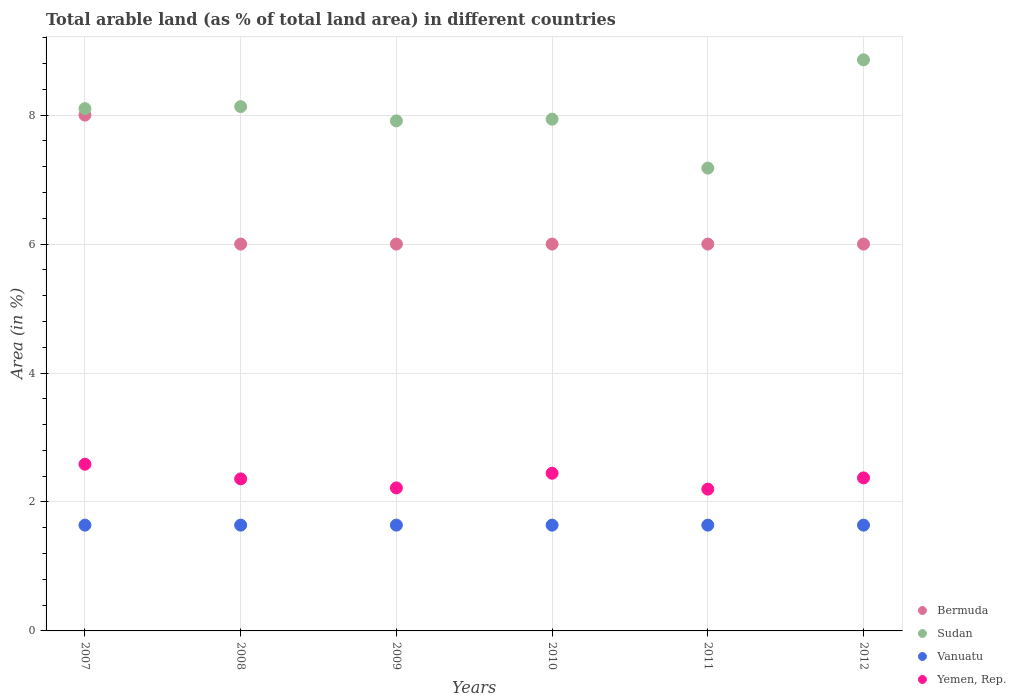How many different coloured dotlines are there?
Your answer should be very brief. 4. Is the number of dotlines equal to the number of legend labels?
Your answer should be very brief. Yes. What is the percentage of arable land in Yemen, Rep. in 2010?
Keep it short and to the point. 2.45. Across all years, what is the maximum percentage of arable land in Yemen, Rep.?
Keep it short and to the point. 2.59. Across all years, what is the minimum percentage of arable land in Yemen, Rep.?
Make the answer very short. 2.2. In which year was the percentage of arable land in Sudan minimum?
Your answer should be compact. 2011. What is the total percentage of arable land in Yemen, Rep. in the graph?
Provide a succinct answer. 14.18. What is the difference between the percentage of arable land in Bermuda in 2007 and that in 2009?
Ensure brevity in your answer.  2. What is the difference between the percentage of arable land in Sudan in 2008 and the percentage of arable land in Vanuatu in 2009?
Your answer should be very brief. 6.49. What is the average percentage of arable land in Sudan per year?
Provide a short and direct response. 8.02. In the year 2008, what is the difference between the percentage of arable land in Bermuda and percentage of arable land in Sudan?
Offer a very short reply. -2.13. Is the difference between the percentage of arable land in Bermuda in 2008 and 2012 greater than the difference between the percentage of arable land in Sudan in 2008 and 2012?
Provide a succinct answer. Yes. What is the difference between the highest and the second highest percentage of arable land in Sudan?
Your answer should be compact. 0.73. What is the difference between the highest and the lowest percentage of arable land in Sudan?
Provide a short and direct response. 1.68. Is it the case that in every year, the sum of the percentage of arable land in Vanuatu and percentage of arable land in Sudan  is greater than the sum of percentage of arable land in Yemen, Rep. and percentage of arable land in Bermuda?
Your answer should be very brief. No. Is it the case that in every year, the sum of the percentage of arable land in Sudan and percentage of arable land in Vanuatu  is greater than the percentage of arable land in Yemen, Rep.?
Your answer should be compact. Yes. Does the percentage of arable land in Bermuda monotonically increase over the years?
Your answer should be compact. No. How many dotlines are there?
Provide a short and direct response. 4. How many years are there in the graph?
Your answer should be very brief. 6. What is the difference between two consecutive major ticks on the Y-axis?
Provide a short and direct response. 2. Does the graph contain any zero values?
Provide a succinct answer. No. Where does the legend appear in the graph?
Your response must be concise. Bottom right. How many legend labels are there?
Offer a very short reply. 4. How are the legend labels stacked?
Offer a terse response. Vertical. What is the title of the graph?
Ensure brevity in your answer.  Total arable land (as % of total land area) in different countries. Does "St. Lucia" appear as one of the legend labels in the graph?
Keep it short and to the point. No. What is the label or title of the Y-axis?
Your answer should be very brief. Area (in %). What is the Area (in %) in Sudan in 2007?
Offer a terse response. 8.1. What is the Area (in %) in Vanuatu in 2007?
Your answer should be very brief. 1.64. What is the Area (in %) of Yemen, Rep. in 2007?
Ensure brevity in your answer.  2.59. What is the Area (in %) in Bermuda in 2008?
Provide a succinct answer. 6. What is the Area (in %) in Sudan in 2008?
Your answer should be very brief. 8.13. What is the Area (in %) in Vanuatu in 2008?
Provide a short and direct response. 1.64. What is the Area (in %) of Yemen, Rep. in 2008?
Offer a very short reply. 2.36. What is the Area (in %) in Sudan in 2009?
Your answer should be very brief. 7.91. What is the Area (in %) in Vanuatu in 2009?
Your answer should be very brief. 1.64. What is the Area (in %) of Yemen, Rep. in 2009?
Your response must be concise. 2.22. What is the Area (in %) of Bermuda in 2010?
Keep it short and to the point. 6. What is the Area (in %) of Sudan in 2010?
Keep it short and to the point. 7.94. What is the Area (in %) in Vanuatu in 2010?
Provide a succinct answer. 1.64. What is the Area (in %) of Yemen, Rep. in 2010?
Offer a terse response. 2.45. What is the Area (in %) of Bermuda in 2011?
Provide a short and direct response. 6. What is the Area (in %) in Sudan in 2011?
Keep it short and to the point. 7.18. What is the Area (in %) in Vanuatu in 2011?
Ensure brevity in your answer.  1.64. What is the Area (in %) in Yemen, Rep. in 2011?
Provide a short and direct response. 2.2. What is the Area (in %) in Bermuda in 2012?
Provide a short and direct response. 6. What is the Area (in %) of Sudan in 2012?
Provide a succinct answer. 8.86. What is the Area (in %) in Vanuatu in 2012?
Keep it short and to the point. 1.64. What is the Area (in %) of Yemen, Rep. in 2012?
Your answer should be very brief. 2.37. Across all years, what is the maximum Area (in %) of Bermuda?
Offer a very short reply. 8. Across all years, what is the maximum Area (in %) in Sudan?
Provide a succinct answer. 8.86. Across all years, what is the maximum Area (in %) in Vanuatu?
Offer a terse response. 1.64. Across all years, what is the maximum Area (in %) of Yemen, Rep.?
Ensure brevity in your answer.  2.59. Across all years, what is the minimum Area (in %) of Sudan?
Offer a very short reply. 7.18. Across all years, what is the minimum Area (in %) of Vanuatu?
Provide a succinct answer. 1.64. Across all years, what is the minimum Area (in %) of Yemen, Rep.?
Provide a short and direct response. 2.2. What is the total Area (in %) of Sudan in the graph?
Make the answer very short. 48.12. What is the total Area (in %) of Vanuatu in the graph?
Offer a very short reply. 9.84. What is the total Area (in %) in Yemen, Rep. in the graph?
Provide a succinct answer. 14.18. What is the difference between the Area (in %) of Sudan in 2007 and that in 2008?
Offer a terse response. -0.03. What is the difference between the Area (in %) in Yemen, Rep. in 2007 and that in 2008?
Provide a succinct answer. 0.23. What is the difference between the Area (in %) of Bermuda in 2007 and that in 2009?
Give a very brief answer. 2. What is the difference between the Area (in %) of Sudan in 2007 and that in 2009?
Provide a succinct answer. 0.19. What is the difference between the Area (in %) in Yemen, Rep. in 2007 and that in 2009?
Offer a very short reply. 0.37. What is the difference between the Area (in %) in Sudan in 2007 and that in 2010?
Offer a terse response. 0.16. What is the difference between the Area (in %) of Vanuatu in 2007 and that in 2010?
Your answer should be compact. 0. What is the difference between the Area (in %) in Yemen, Rep. in 2007 and that in 2010?
Your answer should be very brief. 0.14. What is the difference between the Area (in %) in Sudan in 2007 and that in 2011?
Offer a terse response. 0.92. What is the difference between the Area (in %) in Yemen, Rep. in 2007 and that in 2011?
Your response must be concise. 0.39. What is the difference between the Area (in %) of Sudan in 2007 and that in 2012?
Make the answer very short. -0.76. What is the difference between the Area (in %) of Vanuatu in 2007 and that in 2012?
Your response must be concise. 0. What is the difference between the Area (in %) in Yemen, Rep. in 2007 and that in 2012?
Ensure brevity in your answer.  0.21. What is the difference between the Area (in %) of Bermuda in 2008 and that in 2009?
Ensure brevity in your answer.  0. What is the difference between the Area (in %) in Sudan in 2008 and that in 2009?
Make the answer very short. 0.22. What is the difference between the Area (in %) of Yemen, Rep. in 2008 and that in 2009?
Keep it short and to the point. 0.14. What is the difference between the Area (in %) in Bermuda in 2008 and that in 2010?
Provide a succinct answer. 0. What is the difference between the Area (in %) of Sudan in 2008 and that in 2010?
Keep it short and to the point. 0.19. What is the difference between the Area (in %) of Yemen, Rep. in 2008 and that in 2010?
Provide a succinct answer. -0.09. What is the difference between the Area (in %) in Sudan in 2008 and that in 2011?
Make the answer very short. 0.95. What is the difference between the Area (in %) in Yemen, Rep. in 2008 and that in 2011?
Your response must be concise. 0.16. What is the difference between the Area (in %) of Sudan in 2008 and that in 2012?
Your answer should be very brief. -0.73. What is the difference between the Area (in %) of Vanuatu in 2008 and that in 2012?
Make the answer very short. 0. What is the difference between the Area (in %) of Yemen, Rep. in 2008 and that in 2012?
Make the answer very short. -0.02. What is the difference between the Area (in %) of Bermuda in 2009 and that in 2010?
Provide a short and direct response. 0. What is the difference between the Area (in %) of Sudan in 2009 and that in 2010?
Offer a very short reply. -0.03. What is the difference between the Area (in %) in Yemen, Rep. in 2009 and that in 2010?
Your response must be concise. -0.23. What is the difference between the Area (in %) of Bermuda in 2009 and that in 2011?
Offer a terse response. 0. What is the difference between the Area (in %) in Sudan in 2009 and that in 2011?
Offer a terse response. 0.73. What is the difference between the Area (in %) of Vanuatu in 2009 and that in 2011?
Offer a very short reply. 0. What is the difference between the Area (in %) of Yemen, Rep. in 2009 and that in 2011?
Keep it short and to the point. 0.02. What is the difference between the Area (in %) in Sudan in 2009 and that in 2012?
Your answer should be compact. -0.95. What is the difference between the Area (in %) in Vanuatu in 2009 and that in 2012?
Make the answer very short. 0. What is the difference between the Area (in %) of Yemen, Rep. in 2009 and that in 2012?
Make the answer very short. -0.16. What is the difference between the Area (in %) of Bermuda in 2010 and that in 2011?
Your response must be concise. 0. What is the difference between the Area (in %) in Sudan in 2010 and that in 2011?
Your answer should be very brief. 0.76. What is the difference between the Area (in %) in Yemen, Rep. in 2010 and that in 2011?
Provide a short and direct response. 0.25. What is the difference between the Area (in %) of Bermuda in 2010 and that in 2012?
Your response must be concise. 0. What is the difference between the Area (in %) in Sudan in 2010 and that in 2012?
Provide a short and direct response. -0.92. What is the difference between the Area (in %) of Yemen, Rep. in 2010 and that in 2012?
Provide a succinct answer. 0.07. What is the difference between the Area (in %) of Bermuda in 2011 and that in 2012?
Your response must be concise. 0. What is the difference between the Area (in %) in Sudan in 2011 and that in 2012?
Give a very brief answer. -1.68. What is the difference between the Area (in %) in Yemen, Rep. in 2011 and that in 2012?
Offer a terse response. -0.17. What is the difference between the Area (in %) of Bermuda in 2007 and the Area (in %) of Sudan in 2008?
Give a very brief answer. -0.13. What is the difference between the Area (in %) of Bermuda in 2007 and the Area (in %) of Vanuatu in 2008?
Make the answer very short. 6.36. What is the difference between the Area (in %) of Bermuda in 2007 and the Area (in %) of Yemen, Rep. in 2008?
Your answer should be very brief. 5.64. What is the difference between the Area (in %) in Sudan in 2007 and the Area (in %) in Vanuatu in 2008?
Offer a very short reply. 6.46. What is the difference between the Area (in %) in Sudan in 2007 and the Area (in %) in Yemen, Rep. in 2008?
Keep it short and to the point. 5.74. What is the difference between the Area (in %) of Vanuatu in 2007 and the Area (in %) of Yemen, Rep. in 2008?
Your response must be concise. -0.72. What is the difference between the Area (in %) of Bermuda in 2007 and the Area (in %) of Sudan in 2009?
Make the answer very short. 0.09. What is the difference between the Area (in %) of Bermuda in 2007 and the Area (in %) of Vanuatu in 2009?
Keep it short and to the point. 6.36. What is the difference between the Area (in %) of Bermuda in 2007 and the Area (in %) of Yemen, Rep. in 2009?
Offer a terse response. 5.78. What is the difference between the Area (in %) of Sudan in 2007 and the Area (in %) of Vanuatu in 2009?
Your answer should be very brief. 6.46. What is the difference between the Area (in %) of Sudan in 2007 and the Area (in %) of Yemen, Rep. in 2009?
Make the answer very short. 5.88. What is the difference between the Area (in %) of Vanuatu in 2007 and the Area (in %) of Yemen, Rep. in 2009?
Provide a short and direct response. -0.58. What is the difference between the Area (in %) in Bermuda in 2007 and the Area (in %) in Sudan in 2010?
Give a very brief answer. 0.06. What is the difference between the Area (in %) of Bermuda in 2007 and the Area (in %) of Vanuatu in 2010?
Offer a very short reply. 6.36. What is the difference between the Area (in %) in Bermuda in 2007 and the Area (in %) in Yemen, Rep. in 2010?
Your response must be concise. 5.55. What is the difference between the Area (in %) of Sudan in 2007 and the Area (in %) of Vanuatu in 2010?
Make the answer very short. 6.46. What is the difference between the Area (in %) of Sudan in 2007 and the Area (in %) of Yemen, Rep. in 2010?
Offer a very short reply. 5.66. What is the difference between the Area (in %) of Vanuatu in 2007 and the Area (in %) of Yemen, Rep. in 2010?
Your answer should be very brief. -0.8. What is the difference between the Area (in %) in Bermuda in 2007 and the Area (in %) in Sudan in 2011?
Give a very brief answer. 0.82. What is the difference between the Area (in %) in Bermuda in 2007 and the Area (in %) in Vanuatu in 2011?
Offer a very short reply. 6.36. What is the difference between the Area (in %) in Bermuda in 2007 and the Area (in %) in Yemen, Rep. in 2011?
Make the answer very short. 5.8. What is the difference between the Area (in %) in Sudan in 2007 and the Area (in %) in Vanuatu in 2011?
Offer a terse response. 6.46. What is the difference between the Area (in %) of Sudan in 2007 and the Area (in %) of Yemen, Rep. in 2011?
Offer a very short reply. 5.9. What is the difference between the Area (in %) of Vanuatu in 2007 and the Area (in %) of Yemen, Rep. in 2011?
Provide a short and direct response. -0.56. What is the difference between the Area (in %) in Bermuda in 2007 and the Area (in %) in Sudan in 2012?
Offer a terse response. -0.86. What is the difference between the Area (in %) in Bermuda in 2007 and the Area (in %) in Vanuatu in 2012?
Your answer should be compact. 6.36. What is the difference between the Area (in %) of Bermuda in 2007 and the Area (in %) of Yemen, Rep. in 2012?
Your response must be concise. 5.63. What is the difference between the Area (in %) of Sudan in 2007 and the Area (in %) of Vanuatu in 2012?
Make the answer very short. 6.46. What is the difference between the Area (in %) of Sudan in 2007 and the Area (in %) of Yemen, Rep. in 2012?
Offer a terse response. 5.73. What is the difference between the Area (in %) of Vanuatu in 2007 and the Area (in %) of Yemen, Rep. in 2012?
Provide a succinct answer. -0.73. What is the difference between the Area (in %) in Bermuda in 2008 and the Area (in %) in Sudan in 2009?
Give a very brief answer. -1.91. What is the difference between the Area (in %) in Bermuda in 2008 and the Area (in %) in Vanuatu in 2009?
Ensure brevity in your answer.  4.36. What is the difference between the Area (in %) in Bermuda in 2008 and the Area (in %) in Yemen, Rep. in 2009?
Your answer should be compact. 3.78. What is the difference between the Area (in %) in Sudan in 2008 and the Area (in %) in Vanuatu in 2009?
Give a very brief answer. 6.49. What is the difference between the Area (in %) in Sudan in 2008 and the Area (in %) in Yemen, Rep. in 2009?
Offer a very short reply. 5.91. What is the difference between the Area (in %) in Vanuatu in 2008 and the Area (in %) in Yemen, Rep. in 2009?
Give a very brief answer. -0.58. What is the difference between the Area (in %) of Bermuda in 2008 and the Area (in %) of Sudan in 2010?
Your response must be concise. -1.94. What is the difference between the Area (in %) of Bermuda in 2008 and the Area (in %) of Vanuatu in 2010?
Offer a terse response. 4.36. What is the difference between the Area (in %) in Bermuda in 2008 and the Area (in %) in Yemen, Rep. in 2010?
Your answer should be compact. 3.55. What is the difference between the Area (in %) in Sudan in 2008 and the Area (in %) in Vanuatu in 2010?
Keep it short and to the point. 6.49. What is the difference between the Area (in %) of Sudan in 2008 and the Area (in %) of Yemen, Rep. in 2010?
Make the answer very short. 5.69. What is the difference between the Area (in %) in Vanuatu in 2008 and the Area (in %) in Yemen, Rep. in 2010?
Offer a very short reply. -0.8. What is the difference between the Area (in %) in Bermuda in 2008 and the Area (in %) in Sudan in 2011?
Offer a very short reply. -1.18. What is the difference between the Area (in %) in Bermuda in 2008 and the Area (in %) in Vanuatu in 2011?
Provide a short and direct response. 4.36. What is the difference between the Area (in %) in Bermuda in 2008 and the Area (in %) in Yemen, Rep. in 2011?
Offer a very short reply. 3.8. What is the difference between the Area (in %) in Sudan in 2008 and the Area (in %) in Vanuatu in 2011?
Ensure brevity in your answer.  6.49. What is the difference between the Area (in %) in Sudan in 2008 and the Area (in %) in Yemen, Rep. in 2011?
Provide a succinct answer. 5.93. What is the difference between the Area (in %) in Vanuatu in 2008 and the Area (in %) in Yemen, Rep. in 2011?
Keep it short and to the point. -0.56. What is the difference between the Area (in %) in Bermuda in 2008 and the Area (in %) in Sudan in 2012?
Ensure brevity in your answer.  -2.86. What is the difference between the Area (in %) in Bermuda in 2008 and the Area (in %) in Vanuatu in 2012?
Ensure brevity in your answer.  4.36. What is the difference between the Area (in %) of Bermuda in 2008 and the Area (in %) of Yemen, Rep. in 2012?
Provide a succinct answer. 3.63. What is the difference between the Area (in %) of Sudan in 2008 and the Area (in %) of Vanuatu in 2012?
Provide a short and direct response. 6.49. What is the difference between the Area (in %) in Sudan in 2008 and the Area (in %) in Yemen, Rep. in 2012?
Offer a terse response. 5.76. What is the difference between the Area (in %) of Vanuatu in 2008 and the Area (in %) of Yemen, Rep. in 2012?
Ensure brevity in your answer.  -0.73. What is the difference between the Area (in %) of Bermuda in 2009 and the Area (in %) of Sudan in 2010?
Keep it short and to the point. -1.94. What is the difference between the Area (in %) of Bermuda in 2009 and the Area (in %) of Vanuatu in 2010?
Offer a terse response. 4.36. What is the difference between the Area (in %) of Bermuda in 2009 and the Area (in %) of Yemen, Rep. in 2010?
Your response must be concise. 3.55. What is the difference between the Area (in %) of Sudan in 2009 and the Area (in %) of Vanuatu in 2010?
Give a very brief answer. 6.27. What is the difference between the Area (in %) in Sudan in 2009 and the Area (in %) in Yemen, Rep. in 2010?
Give a very brief answer. 5.47. What is the difference between the Area (in %) in Vanuatu in 2009 and the Area (in %) in Yemen, Rep. in 2010?
Provide a short and direct response. -0.8. What is the difference between the Area (in %) of Bermuda in 2009 and the Area (in %) of Sudan in 2011?
Offer a very short reply. -1.18. What is the difference between the Area (in %) of Bermuda in 2009 and the Area (in %) of Vanuatu in 2011?
Offer a terse response. 4.36. What is the difference between the Area (in %) in Bermuda in 2009 and the Area (in %) in Yemen, Rep. in 2011?
Your response must be concise. 3.8. What is the difference between the Area (in %) in Sudan in 2009 and the Area (in %) in Vanuatu in 2011?
Make the answer very short. 6.27. What is the difference between the Area (in %) in Sudan in 2009 and the Area (in %) in Yemen, Rep. in 2011?
Your answer should be compact. 5.71. What is the difference between the Area (in %) of Vanuatu in 2009 and the Area (in %) of Yemen, Rep. in 2011?
Your answer should be very brief. -0.56. What is the difference between the Area (in %) in Bermuda in 2009 and the Area (in %) in Sudan in 2012?
Give a very brief answer. -2.86. What is the difference between the Area (in %) in Bermuda in 2009 and the Area (in %) in Vanuatu in 2012?
Keep it short and to the point. 4.36. What is the difference between the Area (in %) of Bermuda in 2009 and the Area (in %) of Yemen, Rep. in 2012?
Offer a very short reply. 3.63. What is the difference between the Area (in %) in Sudan in 2009 and the Area (in %) in Vanuatu in 2012?
Give a very brief answer. 6.27. What is the difference between the Area (in %) in Sudan in 2009 and the Area (in %) in Yemen, Rep. in 2012?
Give a very brief answer. 5.54. What is the difference between the Area (in %) in Vanuatu in 2009 and the Area (in %) in Yemen, Rep. in 2012?
Your answer should be very brief. -0.73. What is the difference between the Area (in %) in Bermuda in 2010 and the Area (in %) in Sudan in 2011?
Your answer should be very brief. -1.18. What is the difference between the Area (in %) in Bermuda in 2010 and the Area (in %) in Vanuatu in 2011?
Your response must be concise. 4.36. What is the difference between the Area (in %) of Bermuda in 2010 and the Area (in %) of Yemen, Rep. in 2011?
Your answer should be compact. 3.8. What is the difference between the Area (in %) in Sudan in 2010 and the Area (in %) in Vanuatu in 2011?
Keep it short and to the point. 6.3. What is the difference between the Area (in %) in Sudan in 2010 and the Area (in %) in Yemen, Rep. in 2011?
Your answer should be compact. 5.74. What is the difference between the Area (in %) of Vanuatu in 2010 and the Area (in %) of Yemen, Rep. in 2011?
Keep it short and to the point. -0.56. What is the difference between the Area (in %) of Bermuda in 2010 and the Area (in %) of Sudan in 2012?
Make the answer very short. -2.86. What is the difference between the Area (in %) in Bermuda in 2010 and the Area (in %) in Vanuatu in 2012?
Keep it short and to the point. 4.36. What is the difference between the Area (in %) in Bermuda in 2010 and the Area (in %) in Yemen, Rep. in 2012?
Ensure brevity in your answer.  3.63. What is the difference between the Area (in %) of Sudan in 2010 and the Area (in %) of Vanuatu in 2012?
Ensure brevity in your answer.  6.3. What is the difference between the Area (in %) of Sudan in 2010 and the Area (in %) of Yemen, Rep. in 2012?
Your response must be concise. 5.56. What is the difference between the Area (in %) of Vanuatu in 2010 and the Area (in %) of Yemen, Rep. in 2012?
Provide a short and direct response. -0.73. What is the difference between the Area (in %) in Bermuda in 2011 and the Area (in %) in Sudan in 2012?
Your answer should be compact. -2.86. What is the difference between the Area (in %) in Bermuda in 2011 and the Area (in %) in Vanuatu in 2012?
Give a very brief answer. 4.36. What is the difference between the Area (in %) of Bermuda in 2011 and the Area (in %) of Yemen, Rep. in 2012?
Keep it short and to the point. 3.63. What is the difference between the Area (in %) of Sudan in 2011 and the Area (in %) of Vanuatu in 2012?
Your response must be concise. 5.54. What is the difference between the Area (in %) in Sudan in 2011 and the Area (in %) in Yemen, Rep. in 2012?
Make the answer very short. 4.81. What is the difference between the Area (in %) in Vanuatu in 2011 and the Area (in %) in Yemen, Rep. in 2012?
Make the answer very short. -0.73. What is the average Area (in %) in Bermuda per year?
Provide a succinct answer. 6.33. What is the average Area (in %) in Sudan per year?
Your answer should be compact. 8.02. What is the average Area (in %) of Vanuatu per year?
Offer a very short reply. 1.64. What is the average Area (in %) in Yemen, Rep. per year?
Keep it short and to the point. 2.36. In the year 2007, what is the difference between the Area (in %) in Bermuda and Area (in %) in Sudan?
Offer a very short reply. -0.1. In the year 2007, what is the difference between the Area (in %) in Bermuda and Area (in %) in Vanuatu?
Give a very brief answer. 6.36. In the year 2007, what is the difference between the Area (in %) in Bermuda and Area (in %) in Yemen, Rep.?
Keep it short and to the point. 5.41. In the year 2007, what is the difference between the Area (in %) in Sudan and Area (in %) in Vanuatu?
Your response must be concise. 6.46. In the year 2007, what is the difference between the Area (in %) in Sudan and Area (in %) in Yemen, Rep.?
Your answer should be compact. 5.52. In the year 2007, what is the difference between the Area (in %) of Vanuatu and Area (in %) of Yemen, Rep.?
Your response must be concise. -0.94. In the year 2008, what is the difference between the Area (in %) in Bermuda and Area (in %) in Sudan?
Keep it short and to the point. -2.13. In the year 2008, what is the difference between the Area (in %) of Bermuda and Area (in %) of Vanuatu?
Provide a short and direct response. 4.36. In the year 2008, what is the difference between the Area (in %) in Bermuda and Area (in %) in Yemen, Rep.?
Offer a very short reply. 3.64. In the year 2008, what is the difference between the Area (in %) in Sudan and Area (in %) in Vanuatu?
Your response must be concise. 6.49. In the year 2008, what is the difference between the Area (in %) in Sudan and Area (in %) in Yemen, Rep.?
Give a very brief answer. 5.77. In the year 2008, what is the difference between the Area (in %) in Vanuatu and Area (in %) in Yemen, Rep.?
Your response must be concise. -0.72. In the year 2009, what is the difference between the Area (in %) in Bermuda and Area (in %) in Sudan?
Ensure brevity in your answer.  -1.91. In the year 2009, what is the difference between the Area (in %) of Bermuda and Area (in %) of Vanuatu?
Your answer should be compact. 4.36. In the year 2009, what is the difference between the Area (in %) in Bermuda and Area (in %) in Yemen, Rep.?
Keep it short and to the point. 3.78. In the year 2009, what is the difference between the Area (in %) in Sudan and Area (in %) in Vanuatu?
Make the answer very short. 6.27. In the year 2009, what is the difference between the Area (in %) of Sudan and Area (in %) of Yemen, Rep.?
Make the answer very short. 5.69. In the year 2009, what is the difference between the Area (in %) of Vanuatu and Area (in %) of Yemen, Rep.?
Make the answer very short. -0.58. In the year 2010, what is the difference between the Area (in %) in Bermuda and Area (in %) in Sudan?
Ensure brevity in your answer.  -1.94. In the year 2010, what is the difference between the Area (in %) of Bermuda and Area (in %) of Vanuatu?
Provide a succinct answer. 4.36. In the year 2010, what is the difference between the Area (in %) of Bermuda and Area (in %) of Yemen, Rep.?
Give a very brief answer. 3.55. In the year 2010, what is the difference between the Area (in %) in Sudan and Area (in %) in Vanuatu?
Provide a short and direct response. 6.3. In the year 2010, what is the difference between the Area (in %) of Sudan and Area (in %) of Yemen, Rep.?
Ensure brevity in your answer.  5.49. In the year 2010, what is the difference between the Area (in %) in Vanuatu and Area (in %) in Yemen, Rep.?
Your response must be concise. -0.8. In the year 2011, what is the difference between the Area (in %) of Bermuda and Area (in %) of Sudan?
Give a very brief answer. -1.18. In the year 2011, what is the difference between the Area (in %) in Bermuda and Area (in %) in Vanuatu?
Provide a succinct answer. 4.36. In the year 2011, what is the difference between the Area (in %) in Bermuda and Area (in %) in Yemen, Rep.?
Ensure brevity in your answer.  3.8. In the year 2011, what is the difference between the Area (in %) of Sudan and Area (in %) of Vanuatu?
Keep it short and to the point. 5.54. In the year 2011, what is the difference between the Area (in %) of Sudan and Area (in %) of Yemen, Rep.?
Give a very brief answer. 4.98. In the year 2011, what is the difference between the Area (in %) of Vanuatu and Area (in %) of Yemen, Rep.?
Make the answer very short. -0.56. In the year 2012, what is the difference between the Area (in %) in Bermuda and Area (in %) in Sudan?
Make the answer very short. -2.86. In the year 2012, what is the difference between the Area (in %) in Bermuda and Area (in %) in Vanuatu?
Give a very brief answer. 4.36. In the year 2012, what is the difference between the Area (in %) of Bermuda and Area (in %) of Yemen, Rep.?
Keep it short and to the point. 3.63. In the year 2012, what is the difference between the Area (in %) in Sudan and Area (in %) in Vanuatu?
Offer a terse response. 7.22. In the year 2012, what is the difference between the Area (in %) in Sudan and Area (in %) in Yemen, Rep.?
Your response must be concise. 6.48. In the year 2012, what is the difference between the Area (in %) in Vanuatu and Area (in %) in Yemen, Rep.?
Your answer should be very brief. -0.73. What is the ratio of the Area (in %) in Bermuda in 2007 to that in 2008?
Give a very brief answer. 1.33. What is the ratio of the Area (in %) of Sudan in 2007 to that in 2008?
Your response must be concise. 1. What is the ratio of the Area (in %) in Yemen, Rep. in 2007 to that in 2008?
Provide a succinct answer. 1.1. What is the ratio of the Area (in %) of Yemen, Rep. in 2007 to that in 2009?
Your answer should be compact. 1.17. What is the ratio of the Area (in %) in Sudan in 2007 to that in 2010?
Ensure brevity in your answer.  1.02. What is the ratio of the Area (in %) of Yemen, Rep. in 2007 to that in 2010?
Offer a very short reply. 1.06. What is the ratio of the Area (in %) in Sudan in 2007 to that in 2011?
Keep it short and to the point. 1.13. What is the ratio of the Area (in %) in Yemen, Rep. in 2007 to that in 2011?
Offer a very short reply. 1.18. What is the ratio of the Area (in %) in Bermuda in 2007 to that in 2012?
Provide a succinct answer. 1.33. What is the ratio of the Area (in %) in Sudan in 2007 to that in 2012?
Your response must be concise. 0.91. What is the ratio of the Area (in %) in Vanuatu in 2007 to that in 2012?
Ensure brevity in your answer.  1. What is the ratio of the Area (in %) in Yemen, Rep. in 2007 to that in 2012?
Offer a terse response. 1.09. What is the ratio of the Area (in %) of Bermuda in 2008 to that in 2009?
Keep it short and to the point. 1. What is the ratio of the Area (in %) of Sudan in 2008 to that in 2009?
Your answer should be very brief. 1.03. What is the ratio of the Area (in %) of Yemen, Rep. in 2008 to that in 2009?
Your response must be concise. 1.06. What is the ratio of the Area (in %) of Bermuda in 2008 to that in 2010?
Offer a very short reply. 1. What is the ratio of the Area (in %) of Sudan in 2008 to that in 2010?
Ensure brevity in your answer.  1.02. What is the ratio of the Area (in %) of Yemen, Rep. in 2008 to that in 2010?
Offer a very short reply. 0.96. What is the ratio of the Area (in %) of Sudan in 2008 to that in 2011?
Offer a very short reply. 1.13. What is the ratio of the Area (in %) in Yemen, Rep. in 2008 to that in 2011?
Offer a terse response. 1.07. What is the ratio of the Area (in %) of Bermuda in 2008 to that in 2012?
Your answer should be very brief. 1. What is the ratio of the Area (in %) in Sudan in 2008 to that in 2012?
Offer a terse response. 0.92. What is the ratio of the Area (in %) of Vanuatu in 2009 to that in 2010?
Your response must be concise. 1. What is the ratio of the Area (in %) in Yemen, Rep. in 2009 to that in 2010?
Keep it short and to the point. 0.91. What is the ratio of the Area (in %) of Sudan in 2009 to that in 2011?
Make the answer very short. 1.1. What is the ratio of the Area (in %) of Yemen, Rep. in 2009 to that in 2011?
Provide a short and direct response. 1.01. What is the ratio of the Area (in %) in Bermuda in 2009 to that in 2012?
Provide a succinct answer. 1. What is the ratio of the Area (in %) of Sudan in 2009 to that in 2012?
Offer a very short reply. 0.89. What is the ratio of the Area (in %) of Vanuatu in 2009 to that in 2012?
Make the answer very short. 1. What is the ratio of the Area (in %) in Yemen, Rep. in 2009 to that in 2012?
Your answer should be very brief. 0.93. What is the ratio of the Area (in %) in Sudan in 2010 to that in 2011?
Your answer should be very brief. 1.11. What is the ratio of the Area (in %) in Yemen, Rep. in 2010 to that in 2011?
Your answer should be very brief. 1.11. What is the ratio of the Area (in %) of Bermuda in 2010 to that in 2012?
Keep it short and to the point. 1. What is the ratio of the Area (in %) of Sudan in 2010 to that in 2012?
Make the answer very short. 0.9. What is the ratio of the Area (in %) of Yemen, Rep. in 2010 to that in 2012?
Keep it short and to the point. 1.03. What is the ratio of the Area (in %) of Sudan in 2011 to that in 2012?
Your response must be concise. 0.81. What is the ratio of the Area (in %) of Vanuatu in 2011 to that in 2012?
Give a very brief answer. 1. What is the ratio of the Area (in %) in Yemen, Rep. in 2011 to that in 2012?
Offer a terse response. 0.93. What is the difference between the highest and the second highest Area (in %) of Bermuda?
Your answer should be compact. 2. What is the difference between the highest and the second highest Area (in %) in Sudan?
Ensure brevity in your answer.  0.73. What is the difference between the highest and the second highest Area (in %) in Yemen, Rep.?
Ensure brevity in your answer.  0.14. What is the difference between the highest and the lowest Area (in %) of Bermuda?
Offer a terse response. 2. What is the difference between the highest and the lowest Area (in %) of Sudan?
Offer a terse response. 1.68. What is the difference between the highest and the lowest Area (in %) of Yemen, Rep.?
Give a very brief answer. 0.39. 